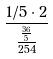<formula> <loc_0><loc_0><loc_500><loc_500>\frac { 1 / 5 \cdot 2 } { \frac { \frac { 3 6 } { 5 } } { 2 5 4 } }</formula> 